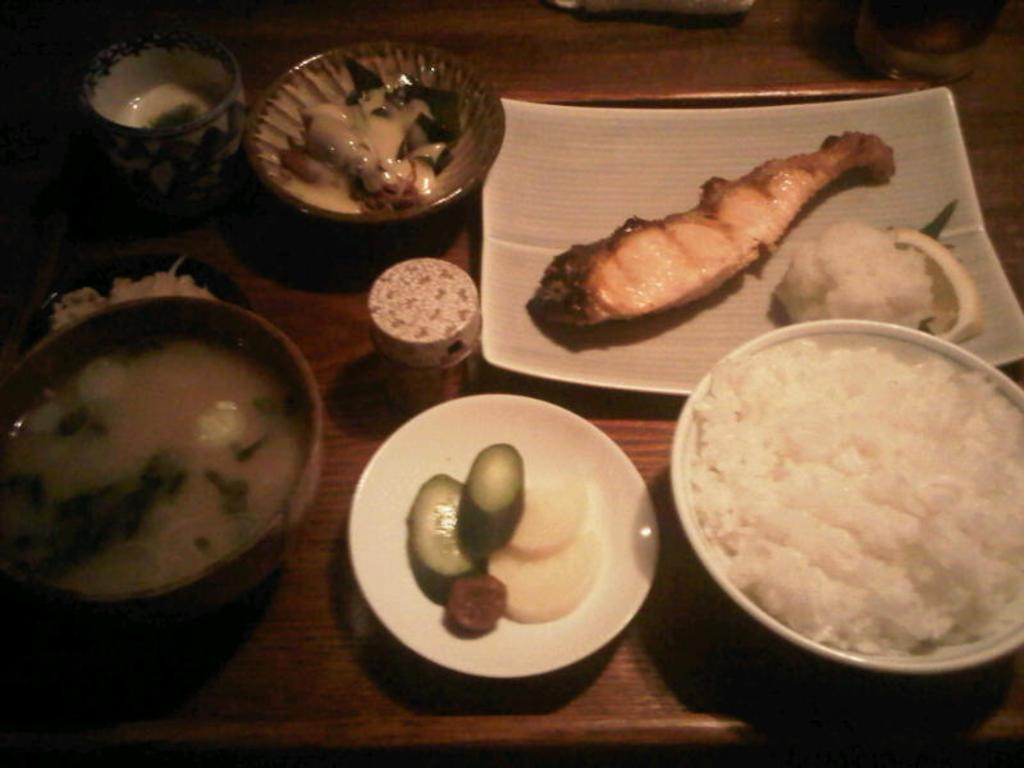What type of containers are visible in the image? There are plates and bowls with food in the image. Where are the plates and bowls located? The plates and bowls are placed on a table. What might be the purpose of the plates and bowls in the image? The plates and bowls are likely used for serving and eating food. How does the beggar interact with the coal in the image? There is no beggar or coal present in the image. 